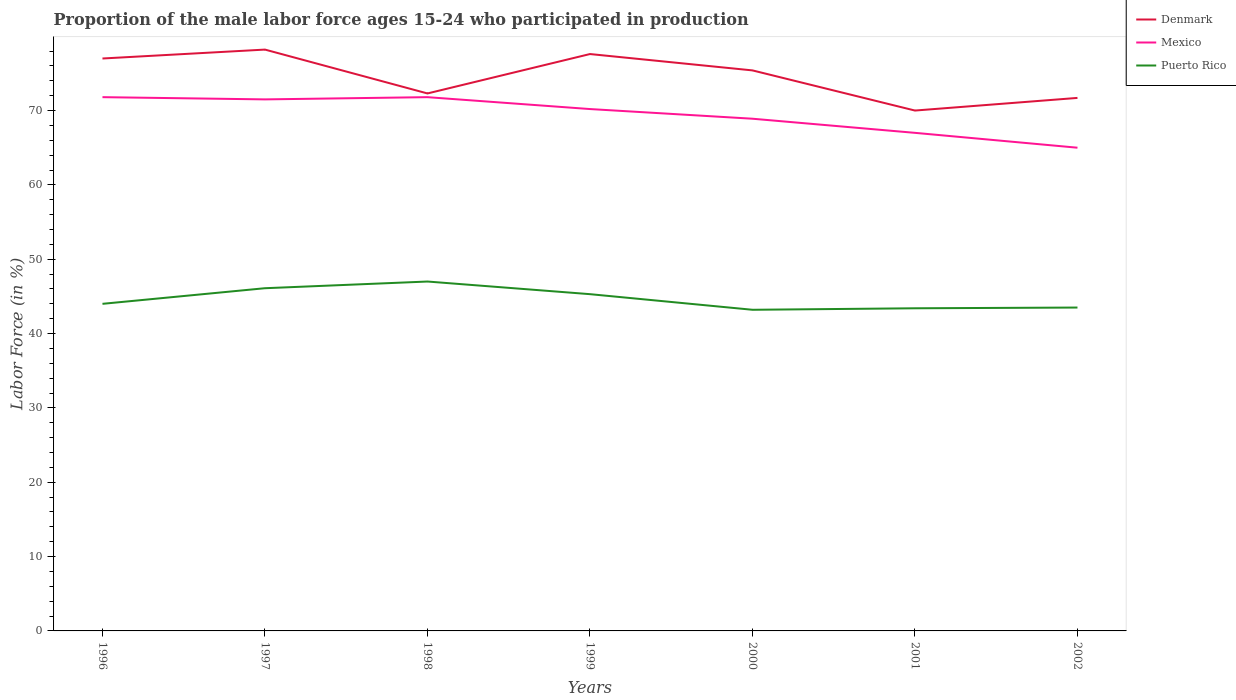How many different coloured lines are there?
Offer a very short reply. 3. Is the number of lines equal to the number of legend labels?
Your answer should be very brief. Yes. What is the total proportion of the male labor force who participated in production in Puerto Rico in the graph?
Make the answer very short. 2.9. What is the difference between the highest and the second highest proportion of the male labor force who participated in production in Puerto Rico?
Keep it short and to the point. 3.8. What is the difference between the highest and the lowest proportion of the male labor force who participated in production in Puerto Rico?
Provide a short and direct response. 3. Is the proportion of the male labor force who participated in production in Mexico strictly greater than the proportion of the male labor force who participated in production in Denmark over the years?
Keep it short and to the point. Yes. How many lines are there?
Ensure brevity in your answer.  3. How many years are there in the graph?
Ensure brevity in your answer.  7. Does the graph contain grids?
Your response must be concise. No. How many legend labels are there?
Give a very brief answer. 3. How are the legend labels stacked?
Give a very brief answer. Vertical. What is the title of the graph?
Make the answer very short. Proportion of the male labor force ages 15-24 who participated in production. What is the label or title of the Y-axis?
Give a very brief answer. Labor Force (in %). What is the Labor Force (in %) of Mexico in 1996?
Provide a short and direct response. 71.8. What is the Labor Force (in %) of Puerto Rico in 1996?
Offer a terse response. 44. What is the Labor Force (in %) in Denmark in 1997?
Provide a short and direct response. 78.2. What is the Labor Force (in %) in Mexico in 1997?
Keep it short and to the point. 71.5. What is the Labor Force (in %) in Puerto Rico in 1997?
Ensure brevity in your answer.  46.1. What is the Labor Force (in %) in Denmark in 1998?
Your response must be concise. 72.3. What is the Labor Force (in %) of Mexico in 1998?
Keep it short and to the point. 71.8. What is the Labor Force (in %) in Denmark in 1999?
Offer a very short reply. 77.6. What is the Labor Force (in %) of Mexico in 1999?
Provide a short and direct response. 70.2. What is the Labor Force (in %) of Puerto Rico in 1999?
Make the answer very short. 45.3. What is the Labor Force (in %) of Denmark in 2000?
Provide a short and direct response. 75.4. What is the Labor Force (in %) of Mexico in 2000?
Offer a terse response. 68.9. What is the Labor Force (in %) in Puerto Rico in 2000?
Your answer should be compact. 43.2. What is the Labor Force (in %) in Mexico in 2001?
Offer a very short reply. 67. What is the Labor Force (in %) of Puerto Rico in 2001?
Give a very brief answer. 43.4. What is the Labor Force (in %) of Denmark in 2002?
Give a very brief answer. 71.7. What is the Labor Force (in %) of Mexico in 2002?
Your answer should be very brief. 65. What is the Labor Force (in %) in Puerto Rico in 2002?
Your answer should be very brief. 43.5. Across all years, what is the maximum Labor Force (in %) in Denmark?
Keep it short and to the point. 78.2. Across all years, what is the maximum Labor Force (in %) of Mexico?
Keep it short and to the point. 71.8. Across all years, what is the maximum Labor Force (in %) in Puerto Rico?
Offer a very short reply. 47. Across all years, what is the minimum Labor Force (in %) of Puerto Rico?
Give a very brief answer. 43.2. What is the total Labor Force (in %) of Denmark in the graph?
Your answer should be compact. 522.2. What is the total Labor Force (in %) of Mexico in the graph?
Ensure brevity in your answer.  486.2. What is the total Labor Force (in %) in Puerto Rico in the graph?
Make the answer very short. 312.5. What is the difference between the Labor Force (in %) in Denmark in 1996 and that in 1997?
Your response must be concise. -1.2. What is the difference between the Labor Force (in %) in Denmark in 1996 and that in 1998?
Give a very brief answer. 4.7. What is the difference between the Labor Force (in %) of Denmark in 1996 and that in 1999?
Offer a terse response. -0.6. What is the difference between the Labor Force (in %) of Mexico in 1996 and that in 2000?
Keep it short and to the point. 2.9. What is the difference between the Labor Force (in %) of Denmark in 1996 and that in 2001?
Offer a very short reply. 7. What is the difference between the Labor Force (in %) of Mexico in 1996 and that in 2001?
Offer a very short reply. 4.8. What is the difference between the Labor Force (in %) in Puerto Rico in 1996 and that in 2001?
Offer a very short reply. 0.6. What is the difference between the Labor Force (in %) in Mexico in 1996 and that in 2002?
Offer a very short reply. 6.8. What is the difference between the Labor Force (in %) in Denmark in 1997 and that in 1998?
Provide a short and direct response. 5.9. What is the difference between the Labor Force (in %) in Denmark in 1997 and that in 1999?
Your response must be concise. 0.6. What is the difference between the Labor Force (in %) of Puerto Rico in 1997 and that in 1999?
Give a very brief answer. 0.8. What is the difference between the Labor Force (in %) of Denmark in 1997 and that in 2001?
Provide a succinct answer. 8.2. What is the difference between the Labor Force (in %) in Denmark in 1997 and that in 2002?
Your response must be concise. 6.5. What is the difference between the Labor Force (in %) of Puerto Rico in 1997 and that in 2002?
Make the answer very short. 2.6. What is the difference between the Labor Force (in %) in Puerto Rico in 1998 and that in 1999?
Your answer should be compact. 1.7. What is the difference between the Labor Force (in %) in Mexico in 1998 and that in 2000?
Provide a succinct answer. 2.9. What is the difference between the Labor Force (in %) in Puerto Rico in 1998 and that in 2000?
Keep it short and to the point. 3.8. What is the difference between the Labor Force (in %) of Denmark in 1998 and that in 2001?
Give a very brief answer. 2.3. What is the difference between the Labor Force (in %) of Puerto Rico in 1998 and that in 2001?
Your response must be concise. 3.6. What is the difference between the Labor Force (in %) in Puerto Rico in 1998 and that in 2002?
Keep it short and to the point. 3.5. What is the difference between the Labor Force (in %) in Puerto Rico in 1999 and that in 2001?
Give a very brief answer. 1.9. What is the difference between the Labor Force (in %) in Denmark in 1999 and that in 2002?
Make the answer very short. 5.9. What is the difference between the Labor Force (in %) in Puerto Rico in 1999 and that in 2002?
Your response must be concise. 1.8. What is the difference between the Labor Force (in %) of Denmark in 2000 and that in 2001?
Provide a short and direct response. 5.4. What is the difference between the Labor Force (in %) of Puerto Rico in 2000 and that in 2001?
Offer a terse response. -0.2. What is the difference between the Labor Force (in %) of Denmark in 1996 and the Labor Force (in %) of Mexico in 1997?
Keep it short and to the point. 5.5. What is the difference between the Labor Force (in %) in Denmark in 1996 and the Labor Force (in %) in Puerto Rico in 1997?
Keep it short and to the point. 30.9. What is the difference between the Labor Force (in %) in Mexico in 1996 and the Labor Force (in %) in Puerto Rico in 1997?
Ensure brevity in your answer.  25.7. What is the difference between the Labor Force (in %) in Denmark in 1996 and the Labor Force (in %) in Puerto Rico in 1998?
Offer a very short reply. 30. What is the difference between the Labor Force (in %) of Mexico in 1996 and the Labor Force (in %) of Puerto Rico in 1998?
Your answer should be compact. 24.8. What is the difference between the Labor Force (in %) of Denmark in 1996 and the Labor Force (in %) of Mexico in 1999?
Give a very brief answer. 6.8. What is the difference between the Labor Force (in %) in Denmark in 1996 and the Labor Force (in %) in Puerto Rico in 1999?
Your response must be concise. 31.7. What is the difference between the Labor Force (in %) in Denmark in 1996 and the Labor Force (in %) in Mexico in 2000?
Offer a very short reply. 8.1. What is the difference between the Labor Force (in %) in Denmark in 1996 and the Labor Force (in %) in Puerto Rico in 2000?
Give a very brief answer. 33.8. What is the difference between the Labor Force (in %) in Mexico in 1996 and the Labor Force (in %) in Puerto Rico in 2000?
Your response must be concise. 28.6. What is the difference between the Labor Force (in %) in Denmark in 1996 and the Labor Force (in %) in Mexico in 2001?
Your answer should be compact. 10. What is the difference between the Labor Force (in %) of Denmark in 1996 and the Labor Force (in %) of Puerto Rico in 2001?
Give a very brief answer. 33.6. What is the difference between the Labor Force (in %) of Mexico in 1996 and the Labor Force (in %) of Puerto Rico in 2001?
Your answer should be compact. 28.4. What is the difference between the Labor Force (in %) of Denmark in 1996 and the Labor Force (in %) of Mexico in 2002?
Offer a terse response. 12. What is the difference between the Labor Force (in %) in Denmark in 1996 and the Labor Force (in %) in Puerto Rico in 2002?
Your response must be concise. 33.5. What is the difference between the Labor Force (in %) of Mexico in 1996 and the Labor Force (in %) of Puerto Rico in 2002?
Ensure brevity in your answer.  28.3. What is the difference between the Labor Force (in %) of Denmark in 1997 and the Labor Force (in %) of Puerto Rico in 1998?
Make the answer very short. 31.2. What is the difference between the Labor Force (in %) of Mexico in 1997 and the Labor Force (in %) of Puerto Rico in 1998?
Provide a succinct answer. 24.5. What is the difference between the Labor Force (in %) of Denmark in 1997 and the Labor Force (in %) of Mexico in 1999?
Keep it short and to the point. 8. What is the difference between the Labor Force (in %) of Denmark in 1997 and the Labor Force (in %) of Puerto Rico in 1999?
Ensure brevity in your answer.  32.9. What is the difference between the Labor Force (in %) of Mexico in 1997 and the Labor Force (in %) of Puerto Rico in 1999?
Offer a very short reply. 26.2. What is the difference between the Labor Force (in %) of Denmark in 1997 and the Labor Force (in %) of Puerto Rico in 2000?
Keep it short and to the point. 35. What is the difference between the Labor Force (in %) of Mexico in 1997 and the Labor Force (in %) of Puerto Rico in 2000?
Your response must be concise. 28.3. What is the difference between the Labor Force (in %) of Denmark in 1997 and the Labor Force (in %) of Mexico in 2001?
Your answer should be very brief. 11.2. What is the difference between the Labor Force (in %) in Denmark in 1997 and the Labor Force (in %) in Puerto Rico in 2001?
Provide a succinct answer. 34.8. What is the difference between the Labor Force (in %) of Mexico in 1997 and the Labor Force (in %) of Puerto Rico in 2001?
Your answer should be compact. 28.1. What is the difference between the Labor Force (in %) of Denmark in 1997 and the Labor Force (in %) of Puerto Rico in 2002?
Offer a very short reply. 34.7. What is the difference between the Labor Force (in %) in Mexico in 1997 and the Labor Force (in %) in Puerto Rico in 2002?
Offer a terse response. 28. What is the difference between the Labor Force (in %) in Denmark in 1998 and the Labor Force (in %) in Puerto Rico in 1999?
Offer a very short reply. 27. What is the difference between the Labor Force (in %) in Denmark in 1998 and the Labor Force (in %) in Puerto Rico in 2000?
Keep it short and to the point. 29.1. What is the difference between the Labor Force (in %) of Mexico in 1998 and the Labor Force (in %) of Puerto Rico in 2000?
Ensure brevity in your answer.  28.6. What is the difference between the Labor Force (in %) of Denmark in 1998 and the Labor Force (in %) of Mexico in 2001?
Provide a succinct answer. 5.3. What is the difference between the Labor Force (in %) of Denmark in 1998 and the Labor Force (in %) of Puerto Rico in 2001?
Your response must be concise. 28.9. What is the difference between the Labor Force (in %) of Mexico in 1998 and the Labor Force (in %) of Puerto Rico in 2001?
Your answer should be very brief. 28.4. What is the difference between the Labor Force (in %) of Denmark in 1998 and the Labor Force (in %) of Mexico in 2002?
Ensure brevity in your answer.  7.3. What is the difference between the Labor Force (in %) of Denmark in 1998 and the Labor Force (in %) of Puerto Rico in 2002?
Offer a terse response. 28.8. What is the difference between the Labor Force (in %) in Mexico in 1998 and the Labor Force (in %) in Puerto Rico in 2002?
Provide a short and direct response. 28.3. What is the difference between the Labor Force (in %) in Denmark in 1999 and the Labor Force (in %) in Puerto Rico in 2000?
Offer a terse response. 34.4. What is the difference between the Labor Force (in %) in Mexico in 1999 and the Labor Force (in %) in Puerto Rico in 2000?
Offer a terse response. 27. What is the difference between the Labor Force (in %) in Denmark in 1999 and the Labor Force (in %) in Puerto Rico in 2001?
Provide a short and direct response. 34.2. What is the difference between the Labor Force (in %) of Mexico in 1999 and the Labor Force (in %) of Puerto Rico in 2001?
Your answer should be compact. 26.8. What is the difference between the Labor Force (in %) of Denmark in 1999 and the Labor Force (in %) of Puerto Rico in 2002?
Make the answer very short. 34.1. What is the difference between the Labor Force (in %) in Mexico in 1999 and the Labor Force (in %) in Puerto Rico in 2002?
Make the answer very short. 26.7. What is the difference between the Labor Force (in %) in Denmark in 2000 and the Labor Force (in %) in Mexico in 2001?
Provide a succinct answer. 8.4. What is the difference between the Labor Force (in %) of Denmark in 2000 and the Labor Force (in %) of Puerto Rico in 2001?
Keep it short and to the point. 32. What is the difference between the Labor Force (in %) of Mexico in 2000 and the Labor Force (in %) of Puerto Rico in 2001?
Your answer should be compact. 25.5. What is the difference between the Labor Force (in %) of Denmark in 2000 and the Labor Force (in %) of Mexico in 2002?
Your response must be concise. 10.4. What is the difference between the Labor Force (in %) in Denmark in 2000 and the Labor Force (in %) in Puerto Rico in 2002?
Make the answer very short. 31.9. What is the difference between the Labor Force (in %) of Mexico in 2000 and the Labor Force (in %) of Puerto Rico in 2002?
Provide a short and direct response. 25.4. What is the difference between the Labor Force (in %) of Denmark in 2001 and the Labor Force (in %) of Mexico in 2002?
Ensure brevity in your answer.  5. What is the average Labor Force (in %) in Denmark per year?
Keep it short and to the point. 74.6. What is the average Labor Force (in %) of Mexico per year?
Provide a succinct answer. 69.46. What is the average Labor Force (in %) of Puerto Rico per year?
Make the answer very short. 44.64. In the year 1996, what is the difference between the Labor Force (in %) of Denmark and Labor Force (in %) of Mexico?
Your answer should be compact. 5.2. In the year 1996, what is the difference between the Labor Force (in %) of Denmark and Labor Force (in %) of Puerto Rico?
Provide a succinct answer. 33. In the year 1996, what is the difference between the Labor Force (in %) of Mexico and Labor Force (in %) of Puerto Rico?
Give a very brief answer. 27.8. In the year 1997, what is the difference between the Labor Force (in %) of Denmark and Labor Force (in %) of Mexico?
Your answer should be compact. 6.7. In the year 1997, what is the difference between the Labor Force (in %) of Denmark and Labor Force (in %) of Puerto Rico?
Keep it short and to the point. 32.1. In the year 1997, what is the difference between the Labor Force (in %) in Mexico and Labor Force (in %) in Puerto Rico?
Give a very brief answer. 25.4. In the year 1998, what is the difference between the Labor Force (in %) of Denmark and Labor Force (in %) of Mexico?
Your answer should be very brief. 0.5. In the year 1998, what is the difference between the Labor Force (in %) of Denmark and Labor Force (in %) of Puerto Rico?
Give a very brief answer. 25.3. In the year 1998, what is the difference between the Labor Force (in %) in Mexico and Labor Force (in %) in Puerto Rico?
Make the answer very short. 24.8. In the year 1999, what is the difference between the Labor Force (in %) in Denmark and Labor Force (in %) in Mexico?
Ensure brevity in your answer.  7.4. In the year 1999, what is the difference between the Labor Force (in %) in Denmark and Labor Force (in %) in Puerto Rico?
Your response must be concise. 32.3. In the year 1999, what is the difference between the Labor Force (in %) of Mexico and Labor Force (in %) of Puerto Rico?
Your answer should be very brief. 24.9. In the year 2000, what is the difference between the Labor Force (in %) of Denmark and Labor Force (in %) of Puerto Rico?
Your answer should be compact. 32.2. In the year 2000, what is the difference between the Labor Force (in %) in Mexico and Labor Force (in %) in Puerto Rico?
Offer a terse response. 25.7. In the year 2001, what is the difference between the Labor Force (in %) in Denmark and Labor Force (in %) in Puerto Rico?
Keep it short and to the point. 26.6. In the year 2001, what is the difference between the Labor Force (in %) in Mexico and Labor Force (in %) in Puerto Rico?
Provide a short and direct response. 23.6. In the year 2002, what is the difference between the Labor Force (in %) of Denmark and Labor Force (in %) of Puerto Rico?
Your response must be concise. 28.2. In the year 2002, what is the difference between the Labor Force (in %) in Mexico and Labor Force (in %) in Puerto Rico?
Give a very brief answer. 21.5. What is the ratio of the Labor Force (in %) of Denmark in 1996 to that in 1997?
Make the answer very short. 0.98. What is the ratio of the Labor Force (in %) in Mexico in 1996 to that in 1997?
Give a very brief answer. 1. What is the ratio of the Labor Force (in %) of Puerto Rico in 1996 to that in 1997?
Ensure brevity in your answer.  0.95. What is the ratio of the Labor Force (in %) in Denmark in 1996 to that in 1998?
Your answer should be very brief. 1.06. What is the ratio of the Labor Force (in %) in Mexico in 1996 to that in 1998?
Give a very brief answer. 1. What is the ratio of the Labor Force (in %) in Puerto Rico in 1996 to that in 1998?
Make the answer very short. 0.94. What is the ratio of the Labor Force (in %) in Mexico in 1996 to that in 1999?
Keep it short and to the point. 1.02. What is the ratio of the Labor Force (in %) in Puerto Rico in 1996 to that in 1999?
Your answer should be very brief. 0.97. What is the ratio of the Labor Force (in %) in Denmark in 1996 to that in 2000?
Provide a succinct answer. 1.02. What is the ratio of the Labor Force (in %) in Mexico in 1996 to that in 2000?
Keep it short and to the point. 1.04. What is the ratio of the Labor Force (in %) in Puerto Rico in 1996 to that in 2000?
Provide a succinct answer. 1.02. What is the ratio of the Labor Force (in %) of Denmark in 1996 to that in 2001?
Offer a terse response. 1.1. What is the ratio of the Labor Force (in %) of Mexico in 1996 to that in 2001?
Your answer should be compact. 1.07. What is the ratio of the Labor Force (in %) of Puerto Rico in 1996 to that in 2001?
Provide a succinct answer. 1.01. What is the ratio of the Labor Force (in %) in Denmark in 1996 to that in 2002?
Keep it short and to the point. 1.07. What is the ratio of the Labor Force (in %) in Mexico in 1996 to that in 2002?
Your response must be concise. 1.1. What is the ratio of the Labor Force (in %) in Puerto Rico in 1996 to that in 2002?
Offer a terse response. 1.01. What is the ratio of the Labor Force (in %) in Denmark in 1997 to that in 1998?
Provide a succinct answer. 1.08. What is the ratio of the Labor Force (in %) in Puerto Rico in 1997 to that in 1998?
Offer a very short reply. 0.98. What is the ratio of the Labor Force (in %) in Denmark in 1997 to that in 1999?
Keep it short and to the point. 1.01. What is the ratio of the Labor Force (in %) of Mexico in 1997 to that in 1999?
Your answer should be compact. 1.02. What is the ratio of the Labor Force (in %) in Puerto Rico in 1997 to that in 1999?
Provide a succinct answer. 1.02. What is the ratio of the Labor Force (in %) in Denmark in 1997 to that in 2000?
Offer a terse response. 1.04. What is the ratio of the Labor Force (in %) in Mexico in 1997 to that in 2000?
Your answer should be very brief. 1.04. What is the ratio of the Labor Force (in %) of Puerto Rico in 1997 to that in 2000?
Offer a terse response. 1.07. What is the ratio of the Labor Force (in %) of Denmark in 1997 to that in 2001?
Ensure brevity in your answer.  1.12. What is the ratio of the Labor Force (in %) in Mexico in 1997 to that in 2001?
Provide a succinct answer. 1.07. What is the ratio of the Labor Force (in %) of Puerto Rico in 1997 to that in 2001?
Make the answer very short. 1.06. What is the ratio of the Labor Force (in %) in Denmark in 1997 to that in 2002?
Ensure brevity in your answer.  1.09. What is the ratio of the Labor Force (in %) of Puerto Rico in 1997 to that in 2002?
Give a very brief answer. 1.06. What is the ratio of the Labor Force (in %) of Denmark in 1998 to that in 1999?
Make the answer very short. 0.93. What is the ratio of the Labor Force (in %) of Mexico in 1998 to that in 1999?
Your answer should be very brief. 1.02. What is the ratio of the Labor Force (in %) in Puerto Rico in 1998 to that in 1999?
Your response must be concise. 1.04. What is the ratio of the Labor Force (in %) in Denmark in 1998 to that in 2000?
Your response must be concise. 0.96. What is the ratio of the Labor Force (in %) of Mexico in 1998 to that in 2000?
Your answer should be very brief. 1.04. What is the ratio of the Labor Force (in %) of Puerto Rico in 1998 to that in 2000?
Your response must be concise. 1.09. What is the ratio of the Labor Force (in %) of Denmark in 1998 to that in 2001?
Provide a succinct answer. 1.03. What is the ratio of the Labor Force (in %) of Mexico in 1998 to that in 2001?
Your answer should be compact. 1.07. What is the ratio of the Labor Force (in %) of Puerto Rico in 1998 to that in 2001?
Your answer should be very brief. 1.08. What is the ratio of the Labor Force (in %) of Denmark in 1998 to that in 2002?
Ensure brevity in your answer.  1.01. What is the ratio of the Labor Force (in %) in Mexico in 1998 to that in 2002?
Ensure brevity in your answer.  1.1. What is the ratio of the Labor Force (in %) of Puerto Rico in 1998 to that in 2002?
Provide a short and direct response. 1.08. What is the ratio of the Labor Force (in %) in Denmark in 1999 to that in 2000?
Your answer should be very brief. 1.03. What is the ratio of the Labor Force (in %) in Mexico in 1999 to that in 2000?
Ensure brevity in your answer.  1.02. What is the ratio of the Labor Force (in %) of Puerto Rico in 1999 to that in 2000?
Your response must be concise. 1.05. What is the ratio of the Labor Force (in %) in Denmark in 1999 to that in 2001?
Ensure brevity in your answer.  1.11. What is the ratio of the Labor Force (in %) of Mexico in 1999 to that in 2001?
Keep it short and to the point. 1.05. What is the ratio of the Labor Force (in %) in Puerto Rico in 1999 to that in 2001?
Keep it short and to the point. 1.04. What is the ratio of the Labor Force (in %) of Denmark in 1999 to that in 2002?
Ensure brevity in your answer.  1.08. What is the ratio of the Labor Force (in %) in Mexico in 1999 to that in 2002?
Make the answer very short. 1.08. What is the ratio of the Labor Force (in %) of Puerto Rico in 1999 to that in 2002?
Give a very brief answer. 1.04. What is the ratio of the Labor Force (in %) of Denmark in 2000 to that in 2001?
Your response must be concise. 1.08. What is the ratio of the Labor Force (in %) in Mexico in 2000 to that in 2001?
Offer a terse response. 1.03. What is the ratio of the Labor Force (in %) of Puerto Rico in 2000 to that in 2001?
Keep it short and to the point. 1. What is the ratio of the Labor Force (in %) in Denmark in 2000 to that in 2002?
Your answer should be very brief. 1.05. What is the ratio of the Labor Force (in %) in Mexico in 2000 to that in 2002?
Give a very brief answer. 1.06. What is the ratio of the Labor Force (in %) of Denmark in 2001 to that in 2002?
Your answer should be compact. 0.98. What is the ratio of the Labor Force (in %) of Mexico in 2001 to that in 2002?
Give a very brief answer. 1.03. What is the difference between the highest and the second highest Labor Force (in %) in Denmark?
Your answer should be compact. 0.6. What is the difference between the highest and the second highest Labor Force (in %) in Mexico?
Keep it short and to the point. 0. What is the difference between the highest and the second highest Labor Force (in %) of Puerto Rico?
Give a very brief answer. 0.9. What is the difference between the highest and the lowest Labor Force (in %) in Mexico?
Provide a succinct answer. 6.8. 